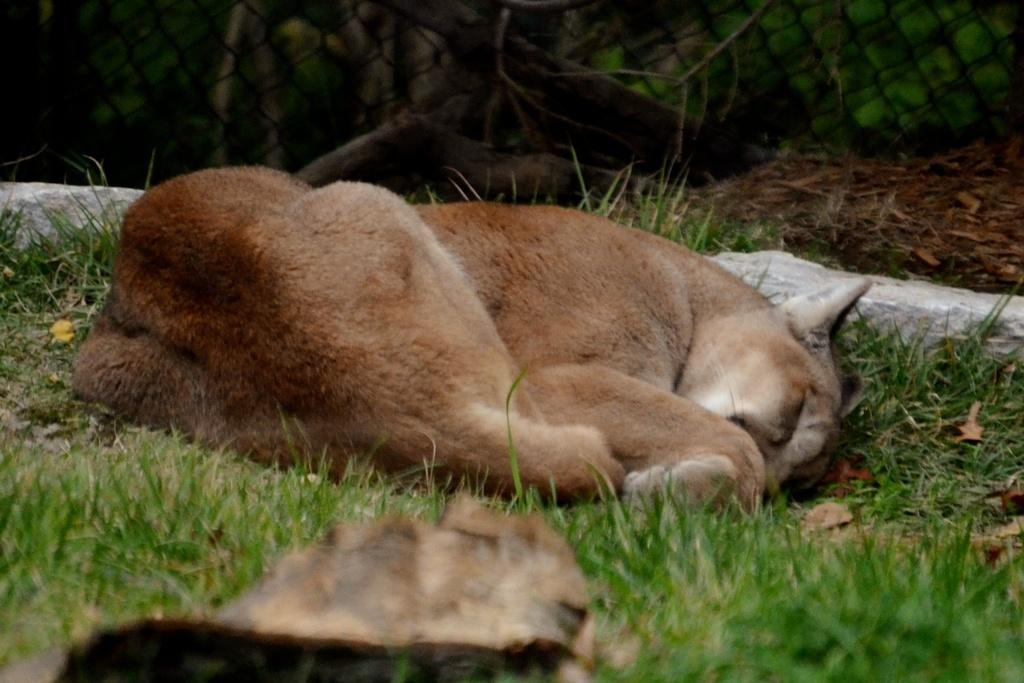What animal can be seen in the image? There is a dog in the image. What is the dog doing in the image? The dog is sleeping in the grass. What object is present at the bottom of the image? There is a stone at the bottom of the image. What can be seen in the background of the image? There is fencing in the background of the image. What type of show is the dog attempting to perform in the image? The image does not depict the dog attempting to perform a show; it shows the dog sleeping in the grass. 